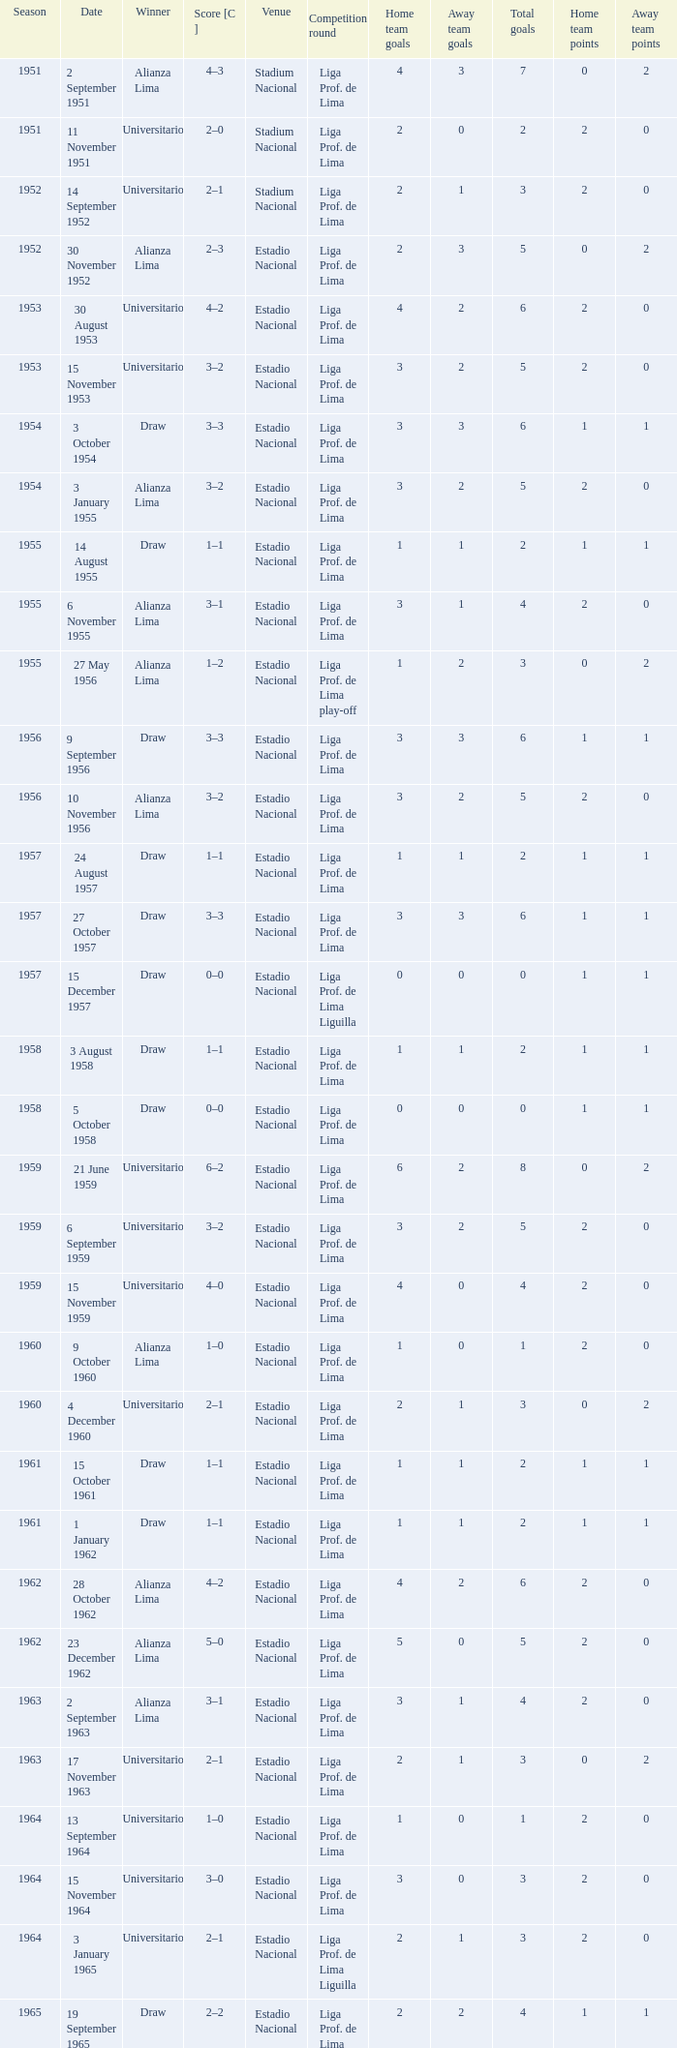Who was the winner on 15 December 1957? Draw. 